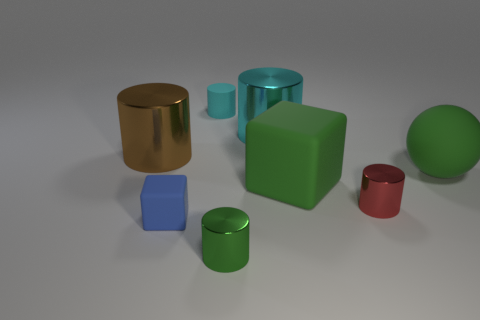What colors are the objects in the image, and do any of them have a reflective surface? The objects in the image come in a variety of colors, including gold, blue, teal, green, lime, red, and brown. The gold and teal objects have reflective metallic surfaces, while the others appear to have matte finishes.  Which object appears to be the largest, and what shape is it? The green cube appears to be the largest object in the image, with distinct edges and faces characteristic of a cube. 